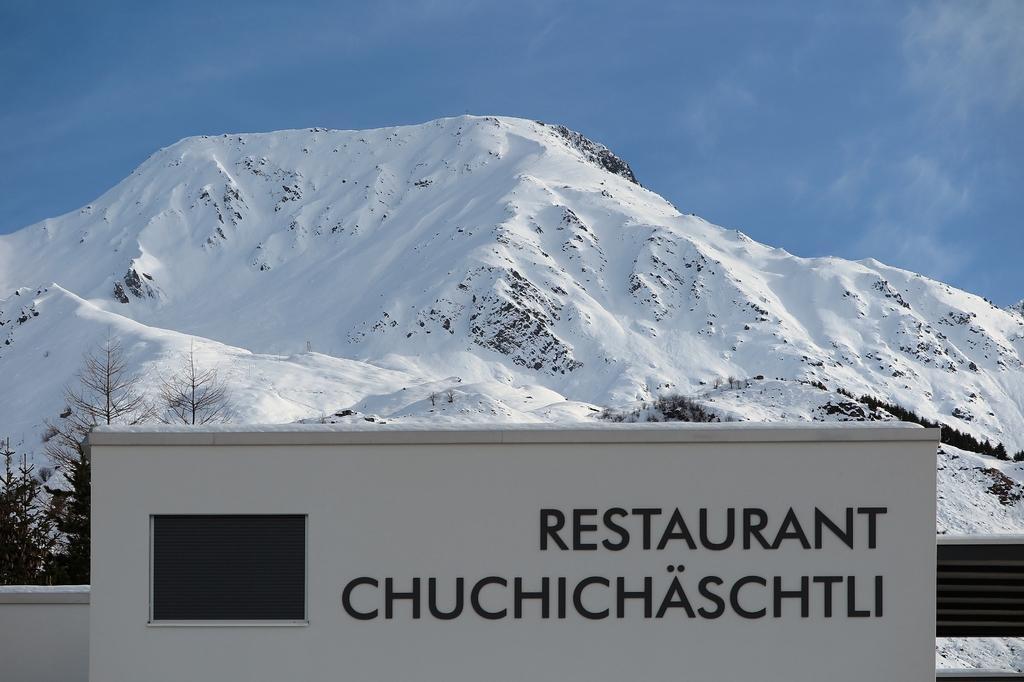How would you summarize this image in a sentence or two? In this picture we can observe a white color wall on which there are black color words. There are some trees. In the background there is a hill which was covered with snow. We can observe a sky here. 